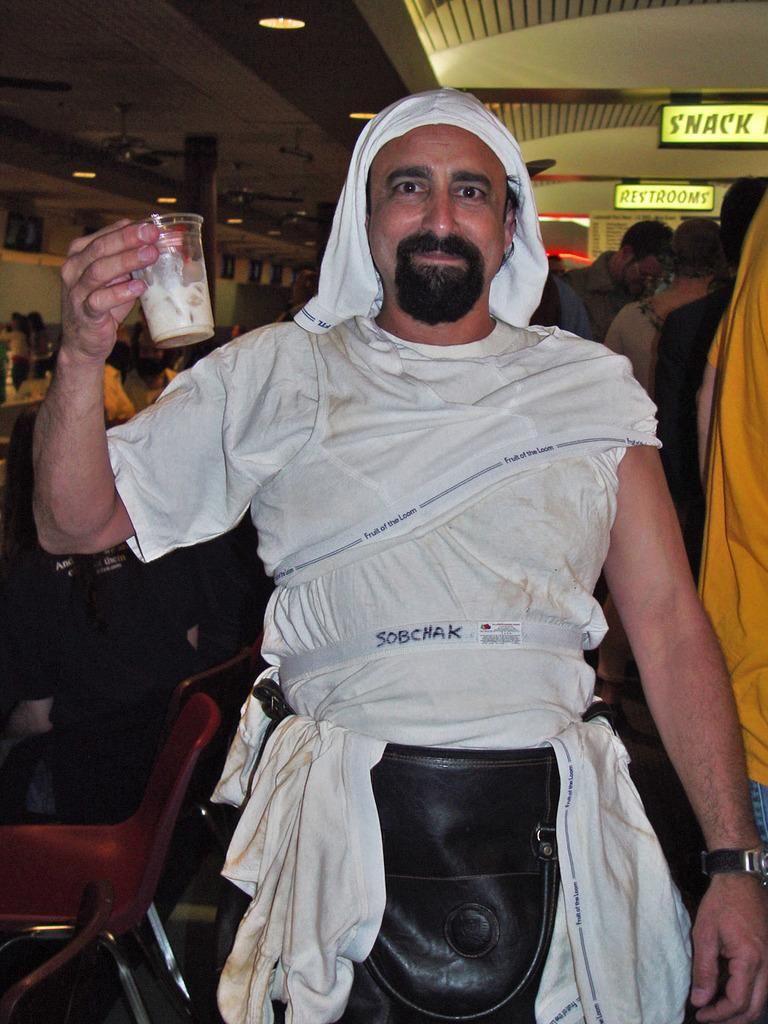Who is present in the image? There is a man in the image. What is the man holding in the image? The man is holding a glass of white drink. Who is the man looking at in the image? The man is looking at someone. What can be seen in the background of the image? There are chairs and people standing under a roof with lights in the background of the image. Reasoning: Let's think step by step by following the provided facts step by step to produce the conversation. We start by identifying the main subject in the image, which is the man. Then, we describe what the man is holding and who he is looking at. Next, we mention the background elements, such as chairs and people under a roof with lights. Each question is designed to elicit a specific detail about the image that is known from the provided facts. Absurd Question/Answer: What type of thread is being used to sew the sun in the image? There is no sun or thread present in the image. 